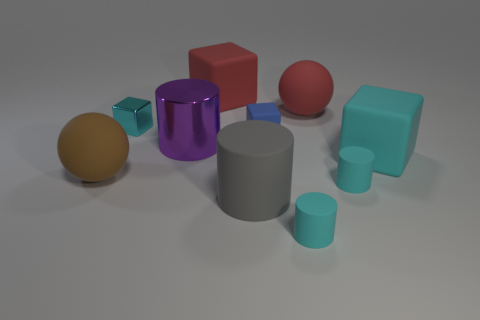Which objects in the image are of the same color? Looking at the image, the large cylinder and the smaller cylinder in the foreground share a cyan hue, suggesting they are of the same color. Are any objects casting noticeable shadows? Yes, you can observe that nearly all objects cast a shadow on the ground, with the direction of the light source being from the upper left, causing the shadows to fall toward the bottom right. 